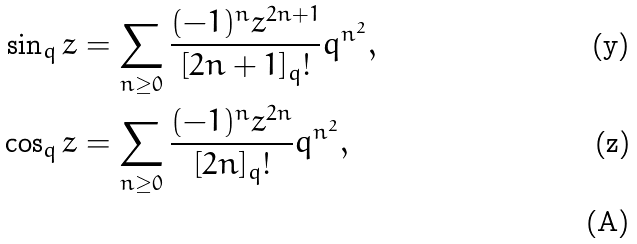Convert formula to latex. <formula><loc_0><loc_0><loc_500><loc_500>\sin _ { q } z & = \sum _ { n \geq 0 } \frac { ( - 1 ) ^ { n } z ^ { 2 n + 1 } } { [ 2 n + 1 ] _ { q } ! } q ^ { n ^ { 2 } } , \\ \cos _ { q } z & = \sum _ { n \geq 0 } \frac { ( - 1 ) ^ { n } z ^ { 2 n } } { [ 2 n ] _ { q } ! } q ^ { n ^ { 2 } } , \\</formula> 